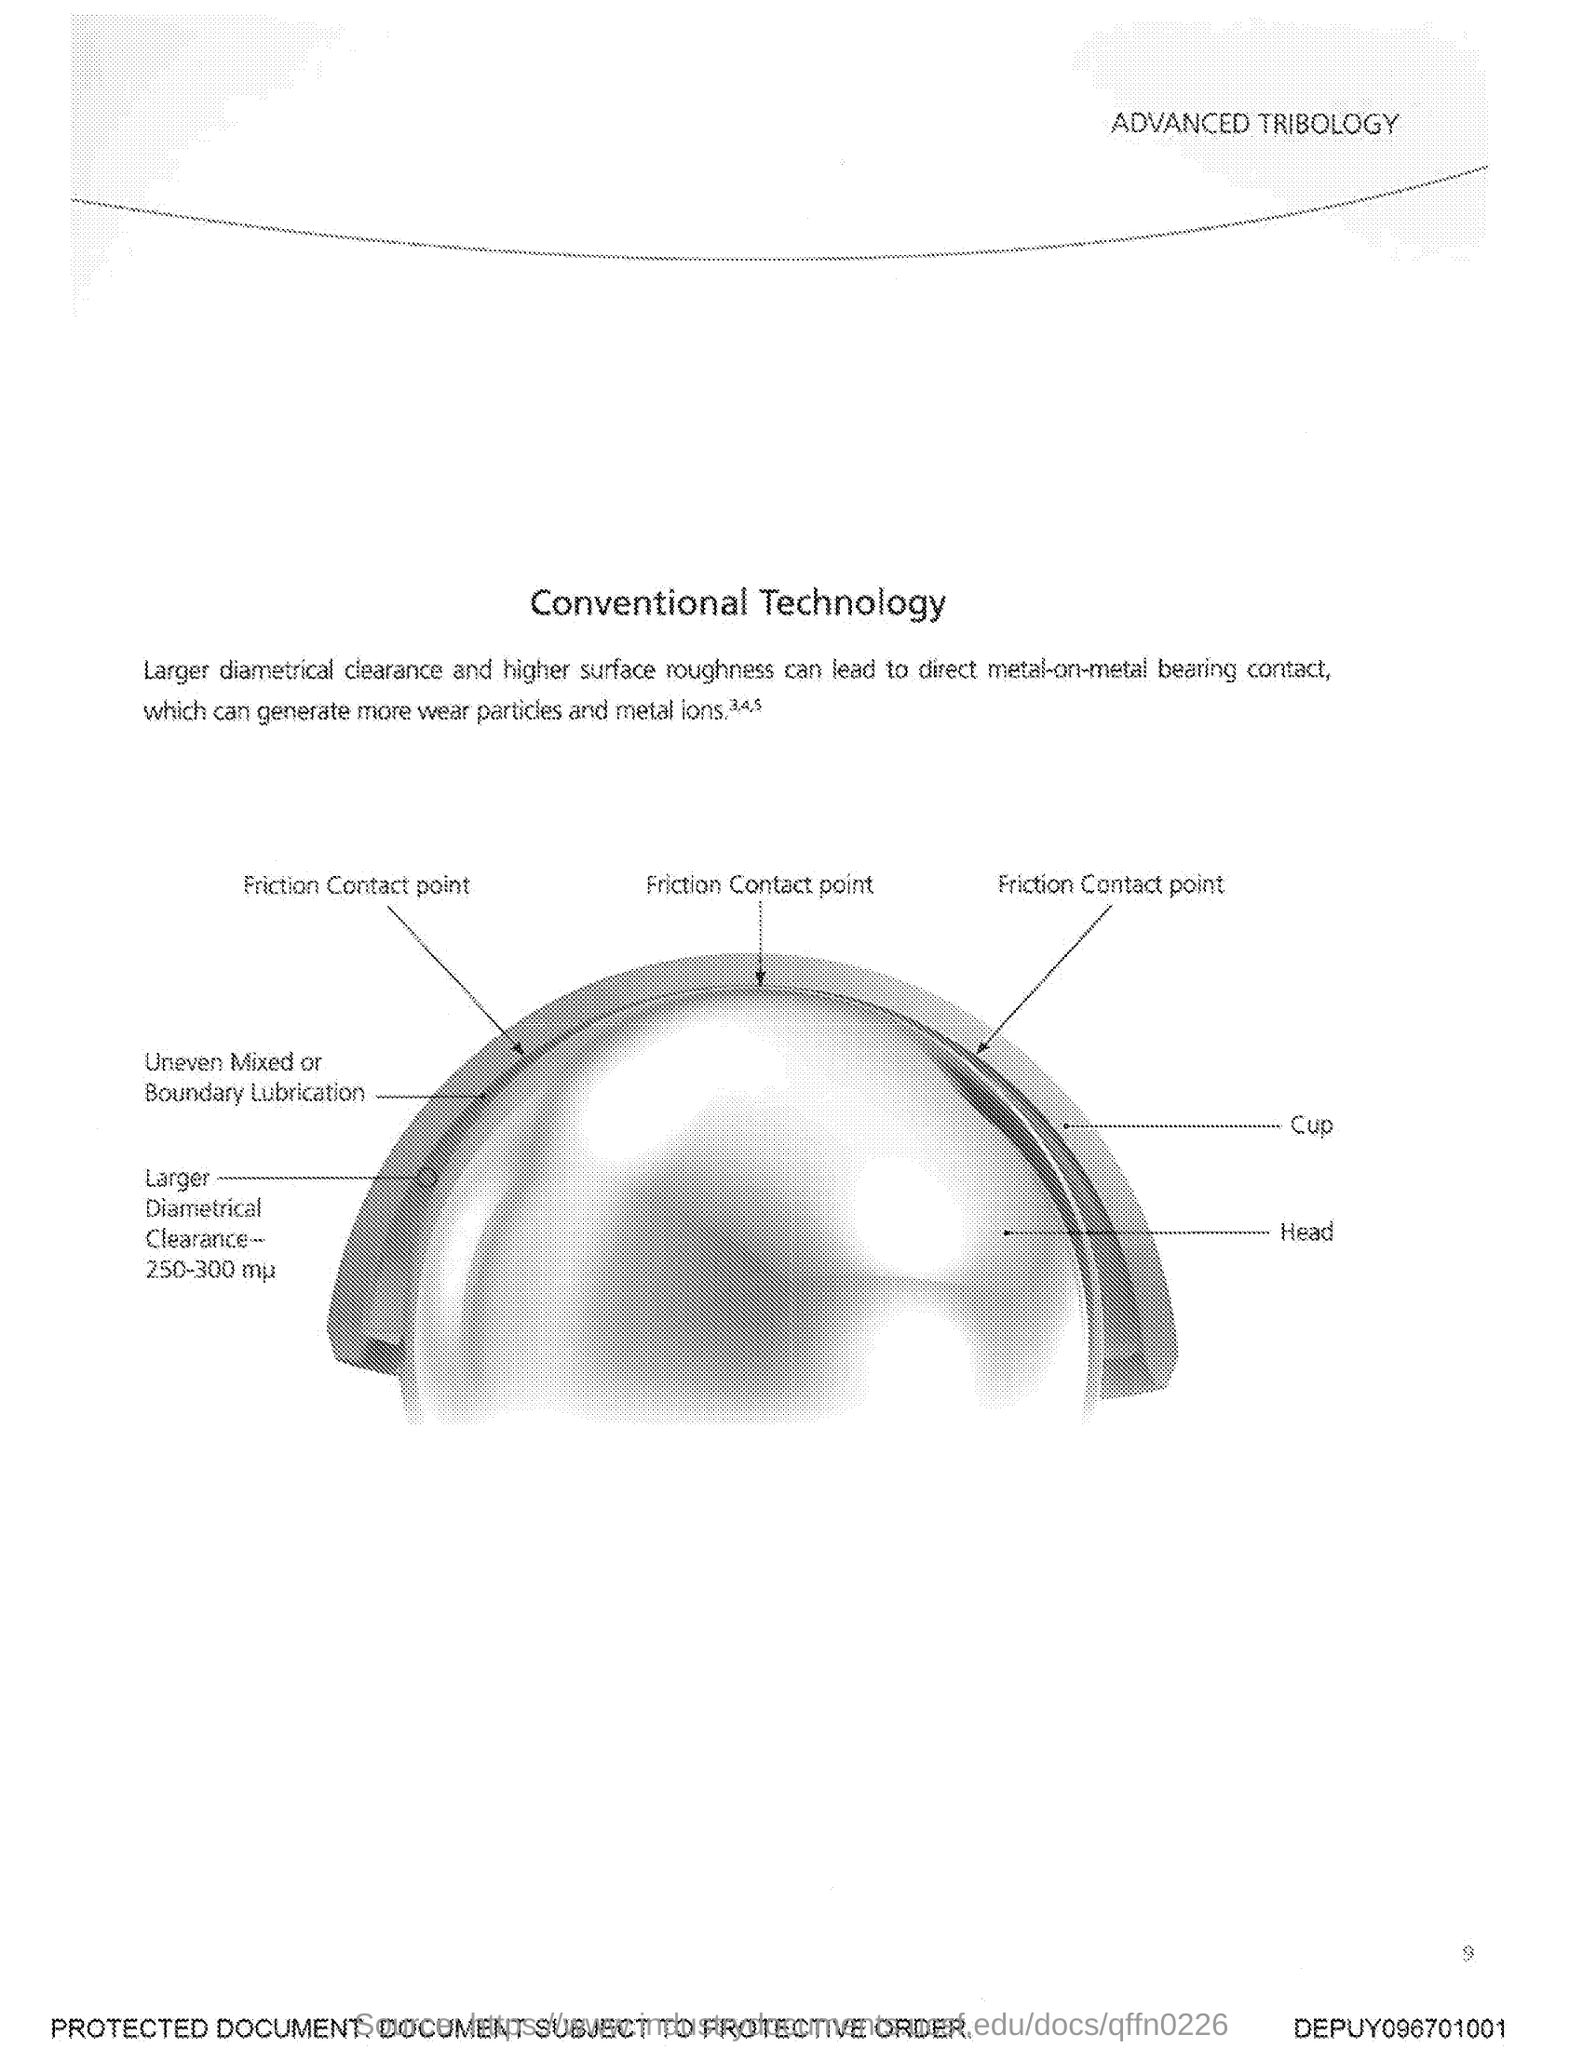What is the title of this document?
Your answer should be very brief. Conventional Technology. 